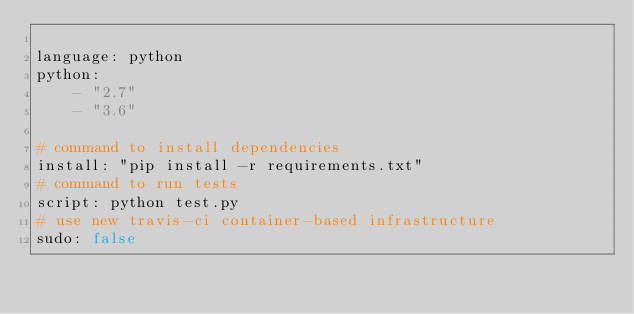Convert code to text. <code><loc_0><loc_0><loc_500><loc_500><_YAML_>
language: python
python:
    - "2.7"
    - "3.6"

# command to install dependencies
install: "pip install -r requirements.txt"
# command to run tests
script: python test.py
# use new travis-ci container-based infrastructure 
sudo: false
</code> 